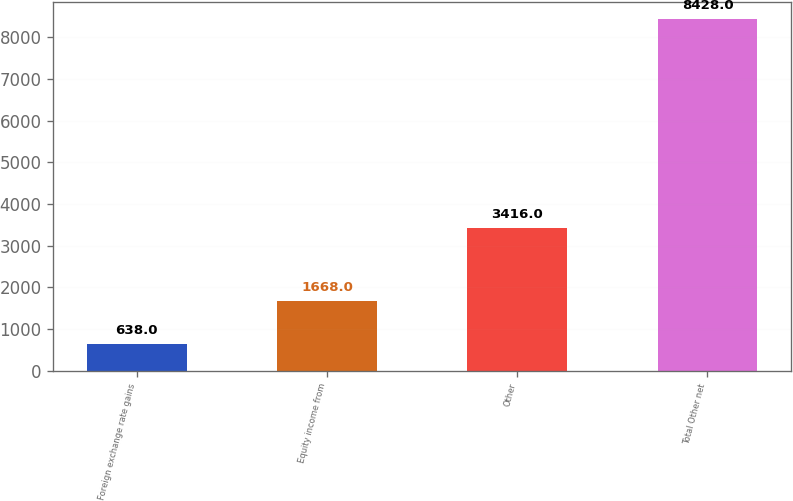<chart> <loc_0><loc_0><loc_500><loc_500><bar_chart><fcel>Foreign exchange rate gains<fcel>Equity income from<fcel>Other<fcel>Total Other net<nl><fcel>638<fcel>1668<fcel>3416<fcel>8428<nl></chart> 